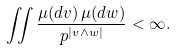Convert formula to latex. <formula><loc_0><loc_0><loc_500><loc_500>\iint \frac { \mu ( d v ) \, \mu ( d w ) } { p ^ { | v \wedge w | } } < \infty .</formula> 